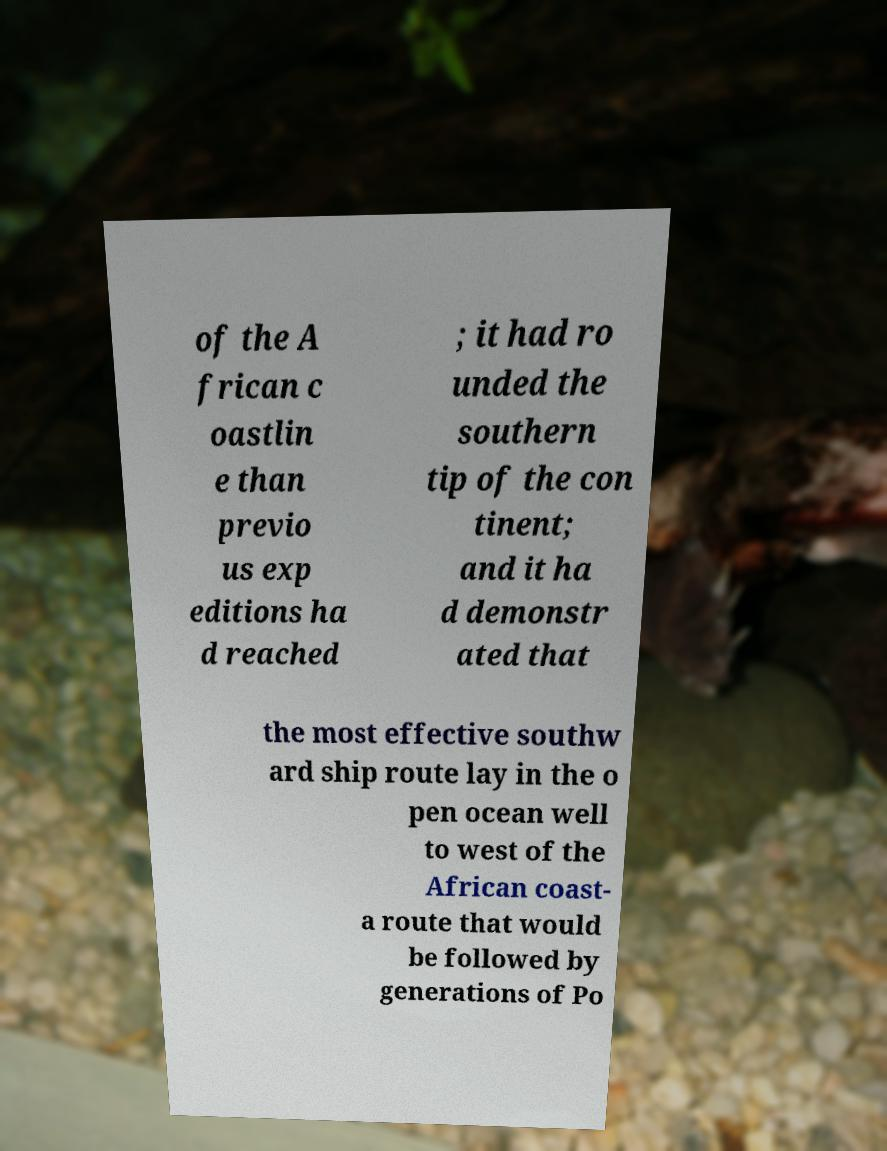Please read and relay the text visible in this image. What does it say? of the A frican c oastlin e than previo us exp editions ha d reached ; it had ro unded the southern tip of the con tinent; and it ha d demonstr ated that the most effective southw ard ship route lay in the o pen ocean well to west of the African coast- a route that would be followed by generations of Po 